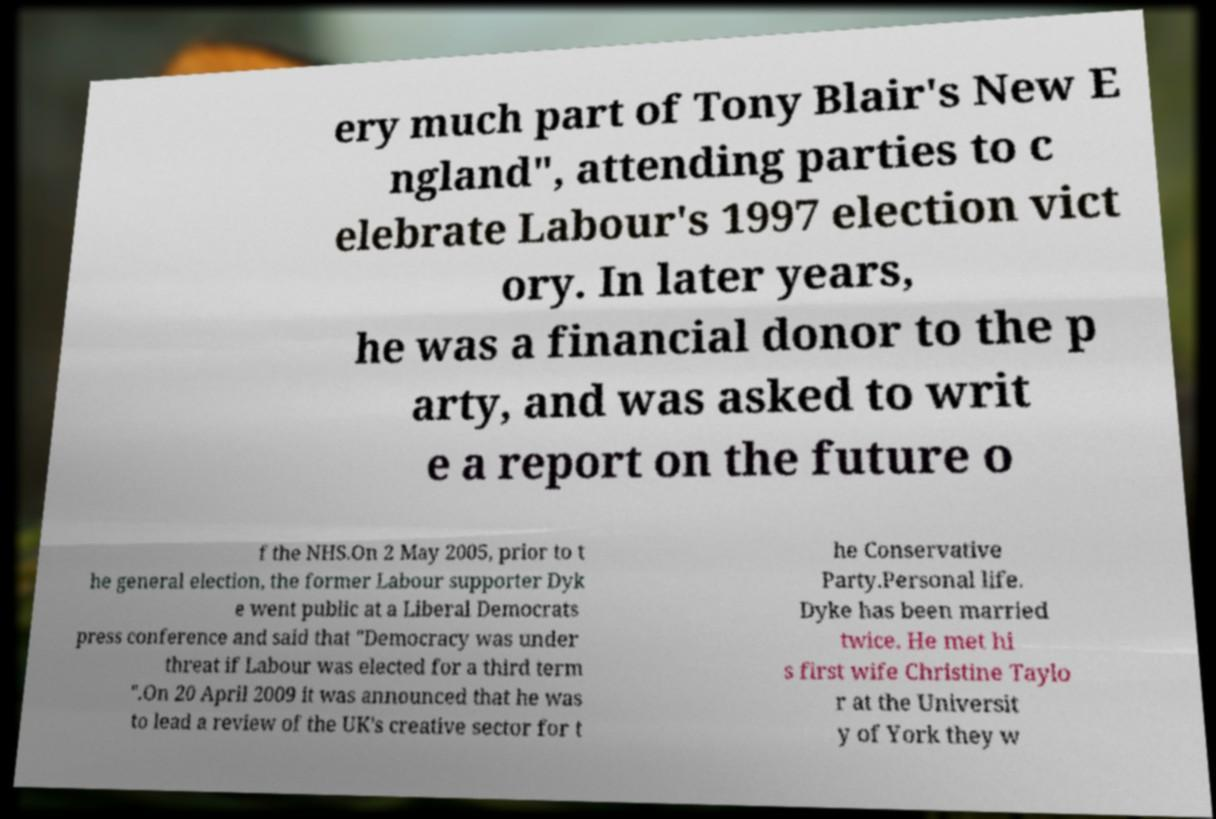Could you assist in decoding the text presented in this image and type it out clearly? ery much part of Tony Blair's New E ngland", attending parties to c elebrate Labour's 1997 election vict ory. In later years, he was a financial donor to the p arty, and was asked to writ e a report on the future o f the NHS.On 2 May 2005, prior to t he general election, the former Labour supporter Dyk e went public at a Liberal Democrats press conference and said that "Democracy was under threat if Labour was elected for a third term ".On 20 April 2009 it was announced that he was to lead a review of the UK's creative sector for t he Conservative Party.Personal life. Dyke has been married twice. He met hi s first wife Christine Taylo r at the Universit y of York they w 